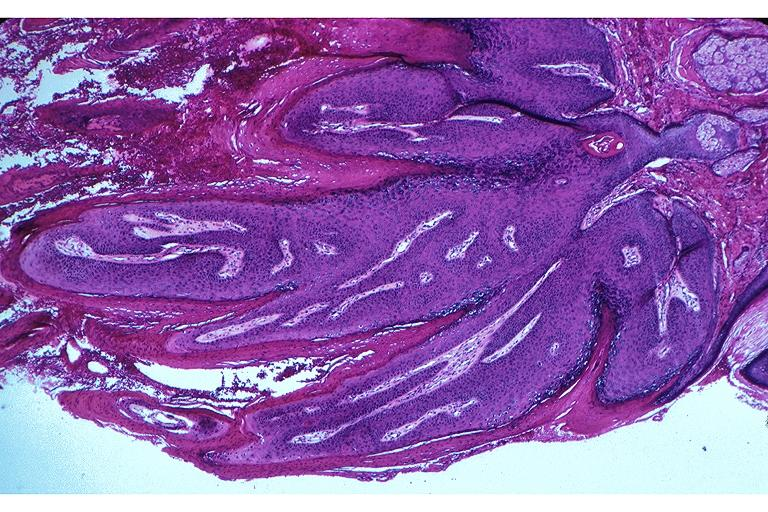s polyarteritis nodosa present?
Answer the question using a single word or phrase. No 